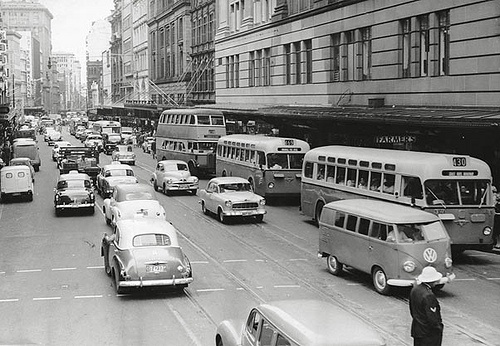Describe the objects in this image and their specific colors. I can see bus in lightgray, black, darkgray, and gray tones, bus in lightgray, gray, darkgray, and black tones, car in lightgray, darkgray, gray, and black tones, car in lightgray, darkgray, black, and gray tones, and bus in lightgray, gray, black, and darkgray tones in this image. 